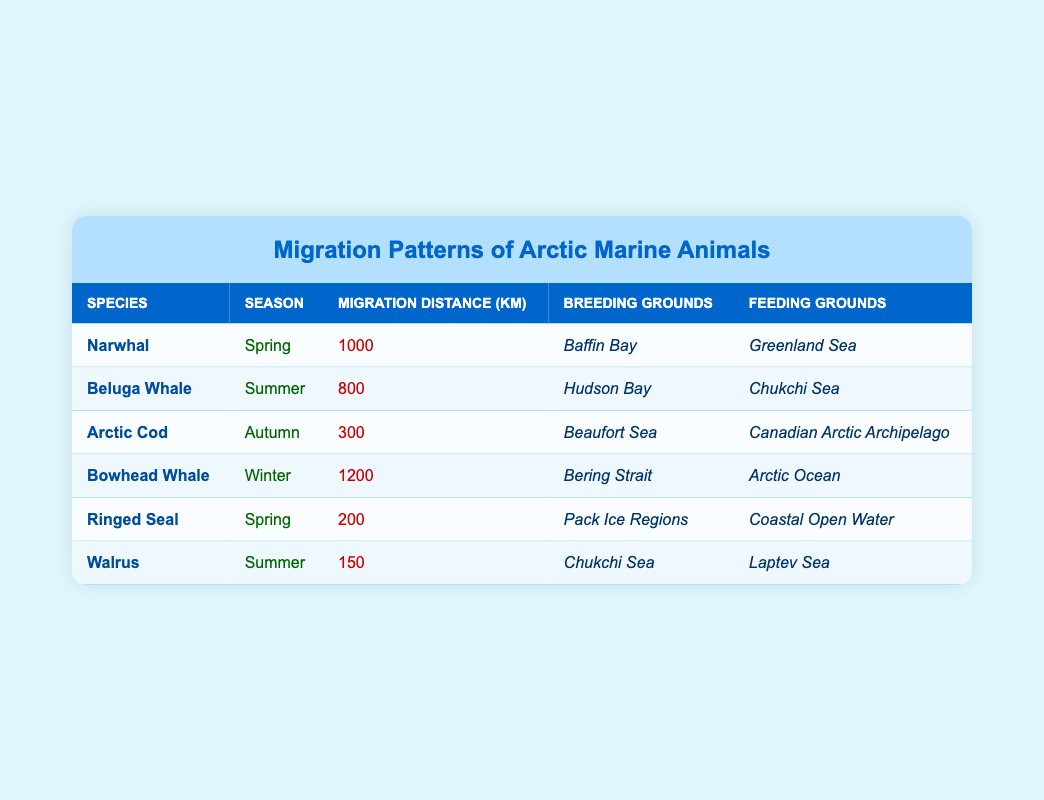What is the migration distance of the Ringed Seal during Spring? The table shows that the Ringed Seal migrates a distance of 200 km during Spring, as indicated in the row for this species and season.
Answer: 200 km Which species migrates the farthest and how far? The Bowhead Whale migrates the farthest distance at 1200 km, as shown in the table under its respective row for the Winter season.
Answer: Bowhead Whale, 1200 km True or False: The Beluga Whale breeds in the Hudson Bay. According to the table, the Beluga Whale's breeding ground is listed as Hudson Bay, so the statement is true.
Answer: True What is the average migration distance for marine animals during the summer season? The table provides migration distances for two species during Summer: Beluga Whale (800 km) and Walrus (150 km). To find the average: (800 + 150) / 2 = 475 km.
Answer: 475 km How many species migrate in Spring and what are their names? The table shows two species that migrate in Spring: Narwhal and Ringed Seal. Thus, there are two species in Spring.
Answer: 2 species: Narwhal, Ringed Seal Which species has the shortest migration distance and what season do they migrate? The species with the shortest migration distance is the Walrus, which migrates a distance of 150 km during Summer, as detailed in its respective row.
Answer: Walrus, Summer, 150 km How does the migration distance of the Arctic Cod compare to that of the Narwhal? The Arctic Cod migrates 300 km in Autumn while the Narwhal migrates 1000 km in Spring. Since 1000 km is greater than 300 km, the Narwhal migrates significantly farther than the Arctic Cod.
Answer: Narwhal migrates farther Does any species breed in the Chukchi Sea? The table indicates that both the Beluga Whale and the Walrus have breeding grounds in the Chukchi Sea. Therefore, the answer is yes.
Answer: Yes Which species migrates during Autumn and what is its food source? The table indicates that the Arctic Cod migrates during Autumn and its feeding ground is the Canadian Arctic Archipelago.
Answer: Arctic Cod, Canadian Arctic Archipelago 